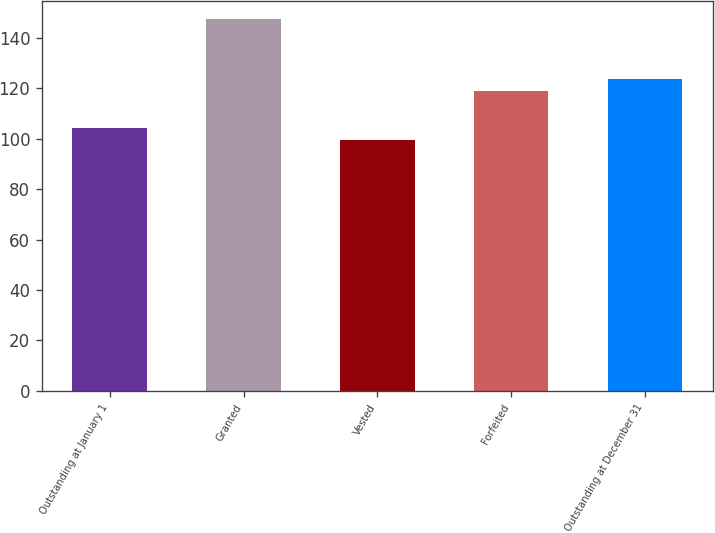<chart> <loc_0><loc_0><loc_500><loc_500><bar_chart><fcel>Outstanding at January 1<fcel>Granted<fcel>Vested<fcel>Forfeited<fcel>Outstanding at December 31<nl><fcel>104.34<fcel>147.44<fcel>99.55<fcel>118.82<fcel>123.61<nl></chart> 